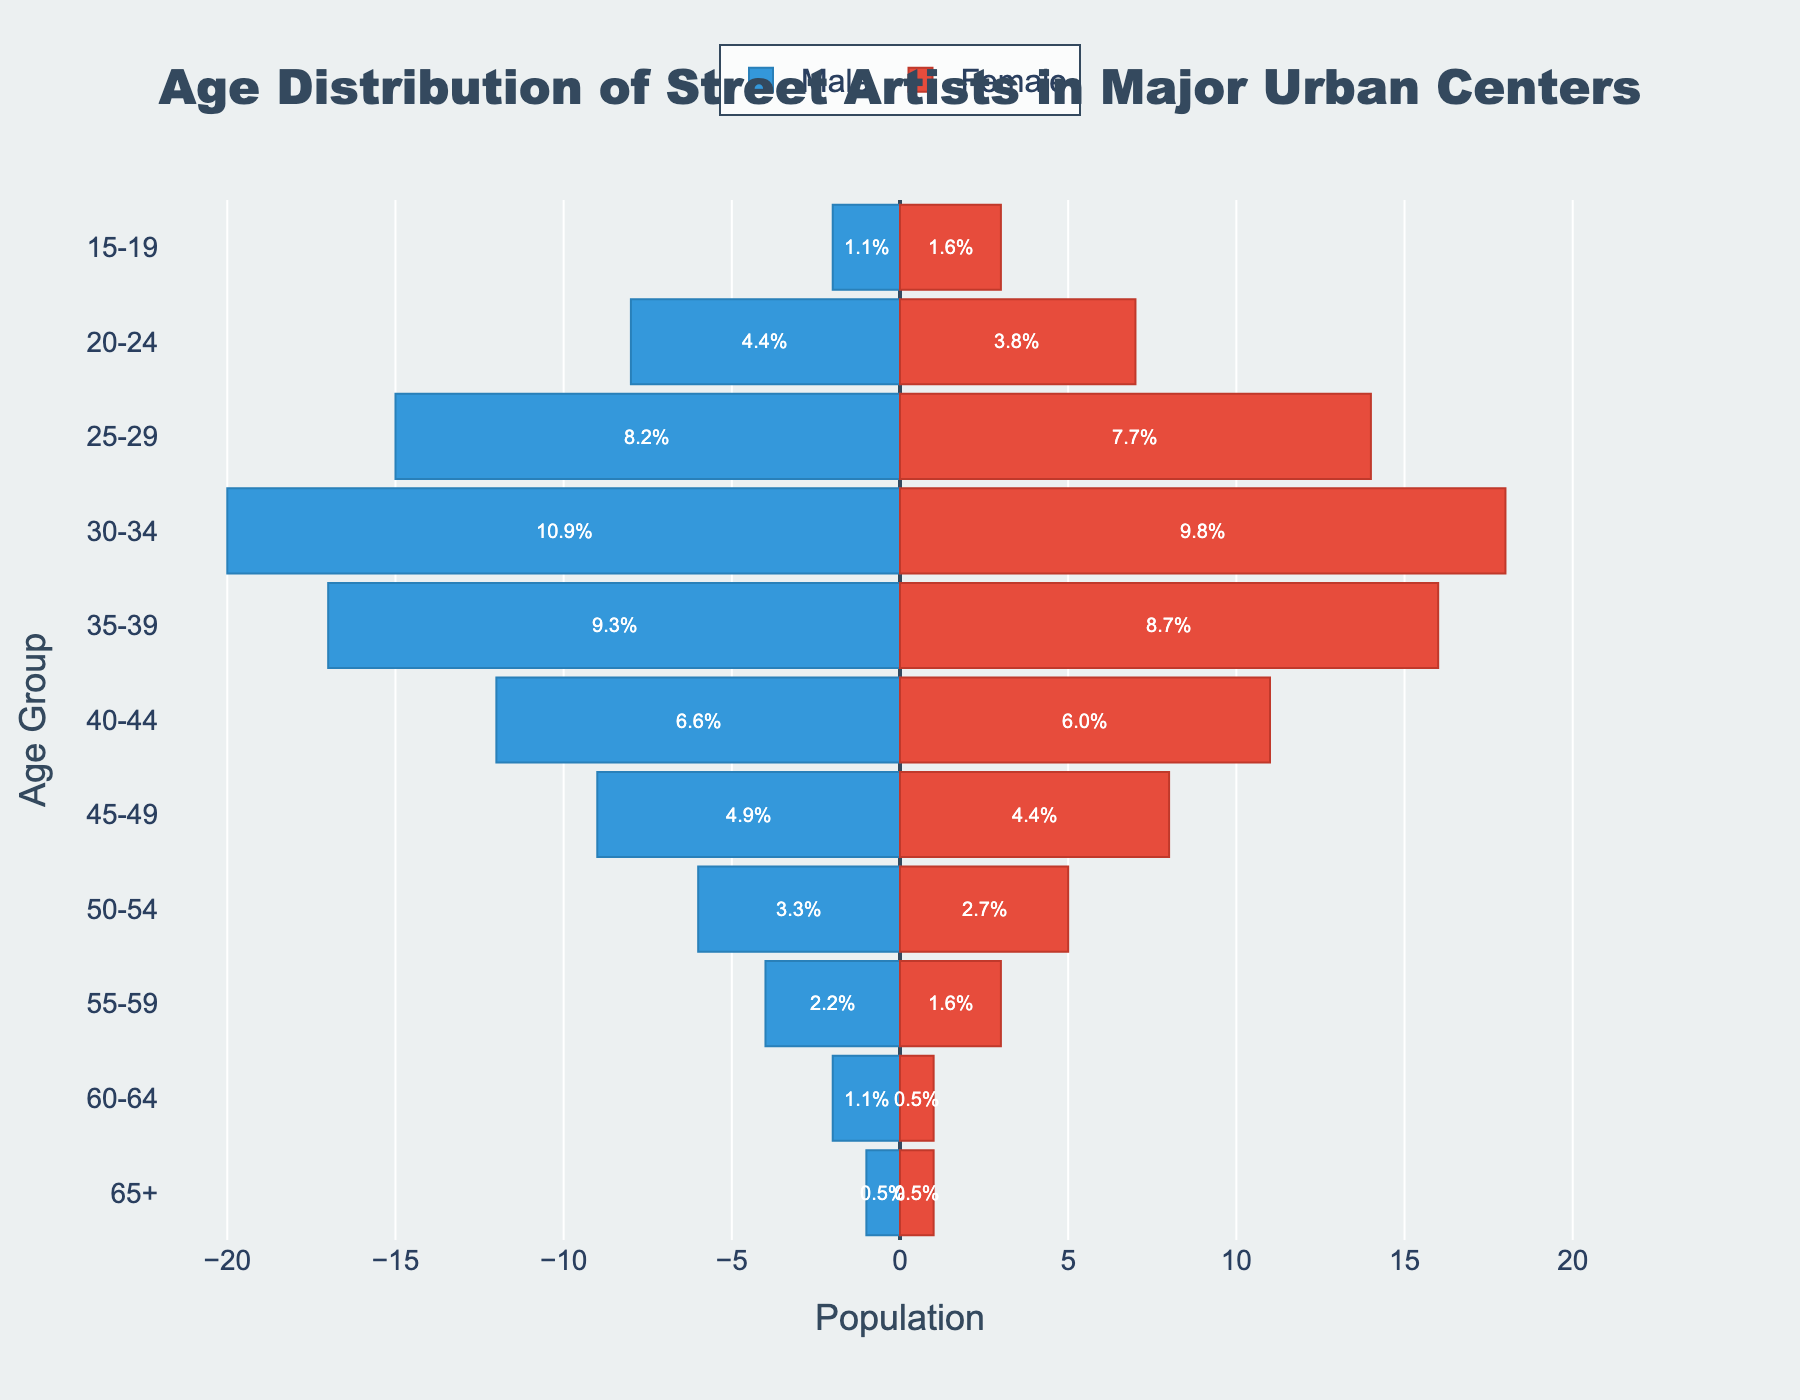What is the title of the figure? The title of the figure is prominently displayed at the top of the chart. It is stylized to catch the viewer's attention.
Answer: Age Distribution of Street Artists in Major Urban Centers Which age group has the highest number of male street artists? By observing the male bars, the longest bar represents the age group with the highest number of male artists.
Answer: 30-34 How many male street artists are in the 25-29 age group? Looking at the male bar corresponding to the 25-29 age group, the length of the bar indicates the value. The male bar is -15.
Answer: 15 What is the total number of female street artists across all age groups? Add the values of all the female bars. The female counts are: 3 + 7 + 14 + 18 + 16 + 11 + 8 + 5 + 3 + 1 + 1, which equals 87.
Answer: 87 What percentage of the total street artists are in the 35-39 age group? Sum the numbers of male and female artists in the 35-39 age group, then divide by the total number of artists and multiply by 100. The calculation is (17 + 16) / (sum of all groups) * 100. The total number of artists is 157. So, (33 / 157) * 100 = 21%.
Answer: 21% Which gender has more street artists in the 45-49 age group? Compare the lengths of the bars for the 45-49 age group. The values are 9 for males and 8 for females.
Answer: Male In which age group do male and female street artists have equal numbers? Find the age group where the lengths of the male and female bars are the same. The only age group with equal counts for both genders is 65+, with 1 male and 1 female.
Answer: 65+ How many street artists are aged 40 and above? Add the values for both genders for age groups starting from 40-44 up to 65+. The calculation is: (12 + 11) + (9 + 8) + (6 + 5) + (4 + 3) + (2 + 1) + (1 + 1) = 30 + 17 + 11 + 7 + 3 + 2 = 70.
Answer: 70 What is the ratio of male to female street artists in the 20-24 age group? Divide the number of male street artists by the number of female street artists in the 20-24 age group. The numbers are 8 males and 7 females. So the ratio is 8/7.
Answer: 8:7 Which age group has the closest number of male and female street artists? Calculate the absolute differences between male and female counts for each age group and find the group with the smallest difference. The smallest difference is in the 65+ age group, where both male and female counts are equal.
Answer: 65+ 